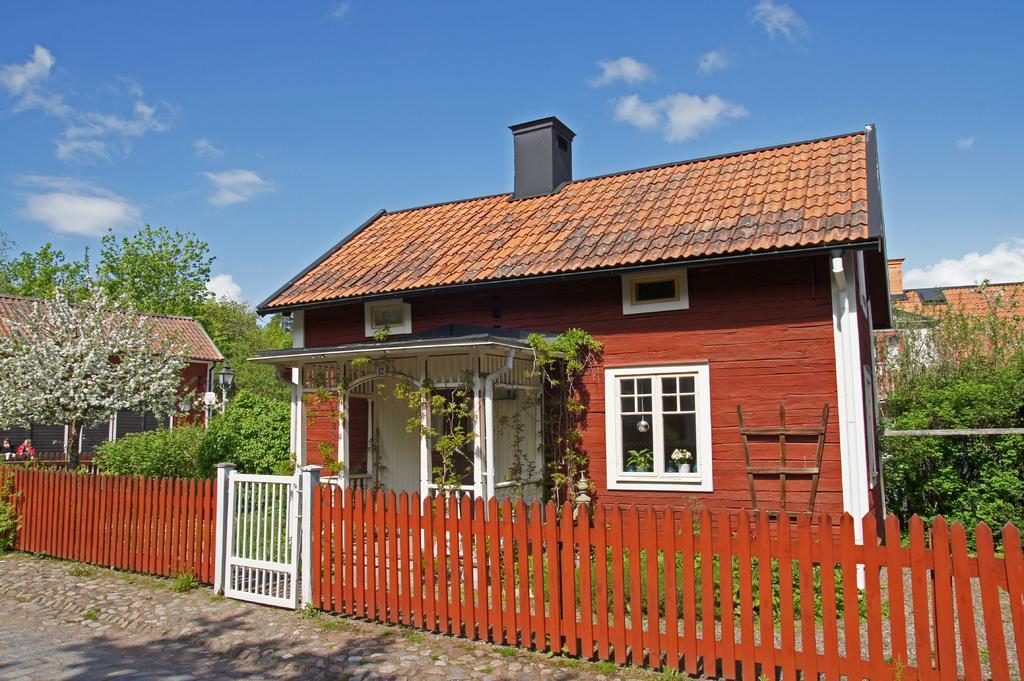Can you describe this image briefly? In this picture we can see the ground, beside this ground we can see a fence, houses, trees, people and in the background we can see sky with clouds. 